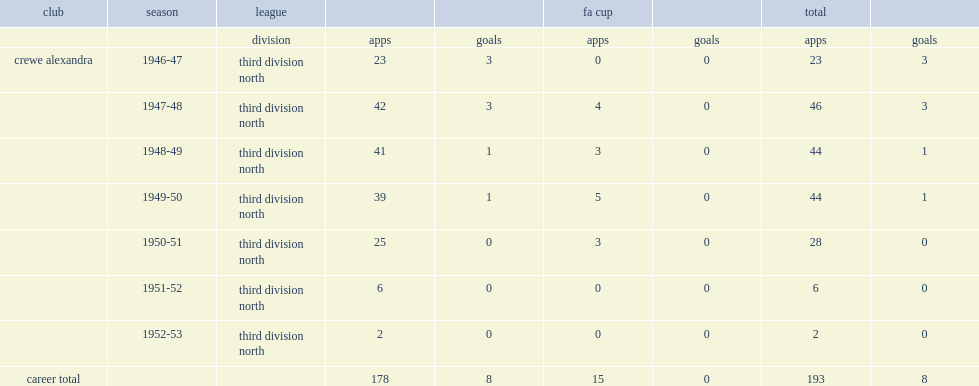Tony waddington played seven seasons in the third division north, how many appearances did he make? 193.0. Tony waddington played seven seasons in the third division north, how many goals did he score? 8.0. 